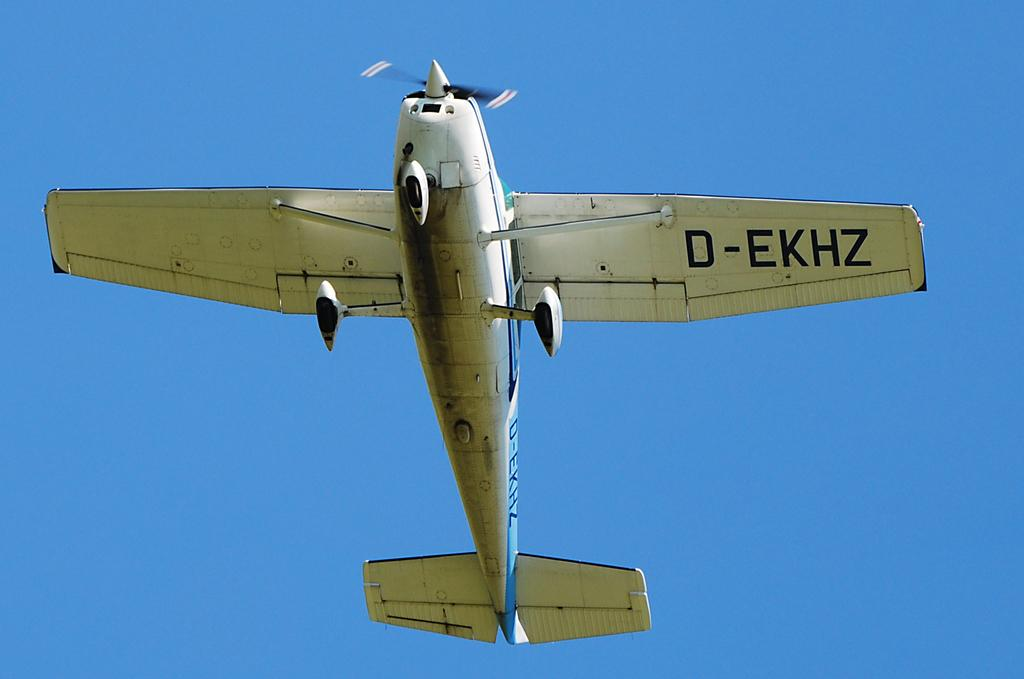What is the main subject of the image? The main subject of the image is an aircraft. What is the aircraft doing in the image? The aircraft is flying in the air. What can be seen in the background of the image? The sky is visible in the background of the image. What is the color of the sky in the image? The color of the sky in the image is blue. How many thumbs can be seen on the aircraft in the image? There are no thumbs visible on the aircraft in the image, as it is a machine and not a living being. 